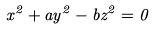Convert formula to latex. <formula><loc_0><loc_0><loc_500><loc_500>x ^ { 2 } + a y ^ { 2 } - b z ^ { 2 } = 0</formula> 